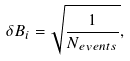Convert formula to latex. <formula><loc_0><loc_0><loc_500><loc_500>\delta B _ { i } = \sqrt { \frac { 1 } { N _ { e v e n t s } } } ,</formula> 